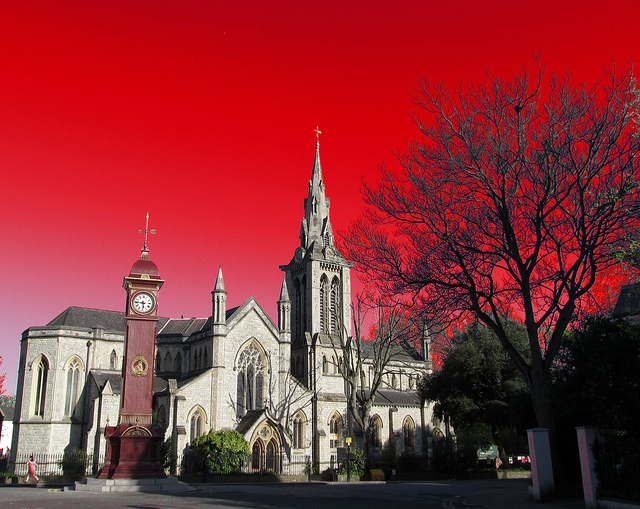Describe the objects in this image and their specific colors. I can see clock in brown, white, darkgray, and gray tones and people in brown, lightpink, gray, darkgray, and black tones in this image. 